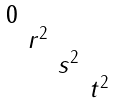<formula> <loc_0><loc_0><loc_500><loc_500>\begin{smallmatrix} 0 & & & \\ & r ^ { 2 } & & \\ & & s ^ { 2 } & \\ & & & t ^ { 2 } \end{smallmatrix}</formula> 